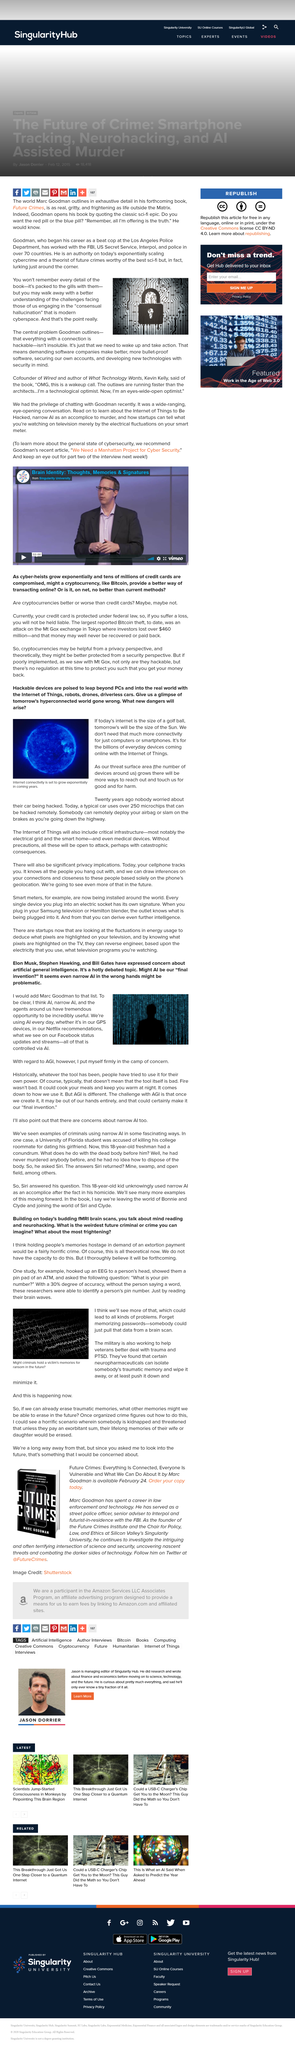Draw attention to some important aspects in this diagram. Marc's Twitter handle is @FutureCrimes. Bitcoin is the kind of cryptocurrency that is mentioned in the caption. The title of the video is "Brain Identity: Thoughts, Memories & Signatures. An EEG is a device that measures and records brain waves, and it typically attaches to a person's head using small electrodes that are placed on the scalp. The exponential growth of internet connectivity in the coming years is set to transform the way we live, work, and communicate. 